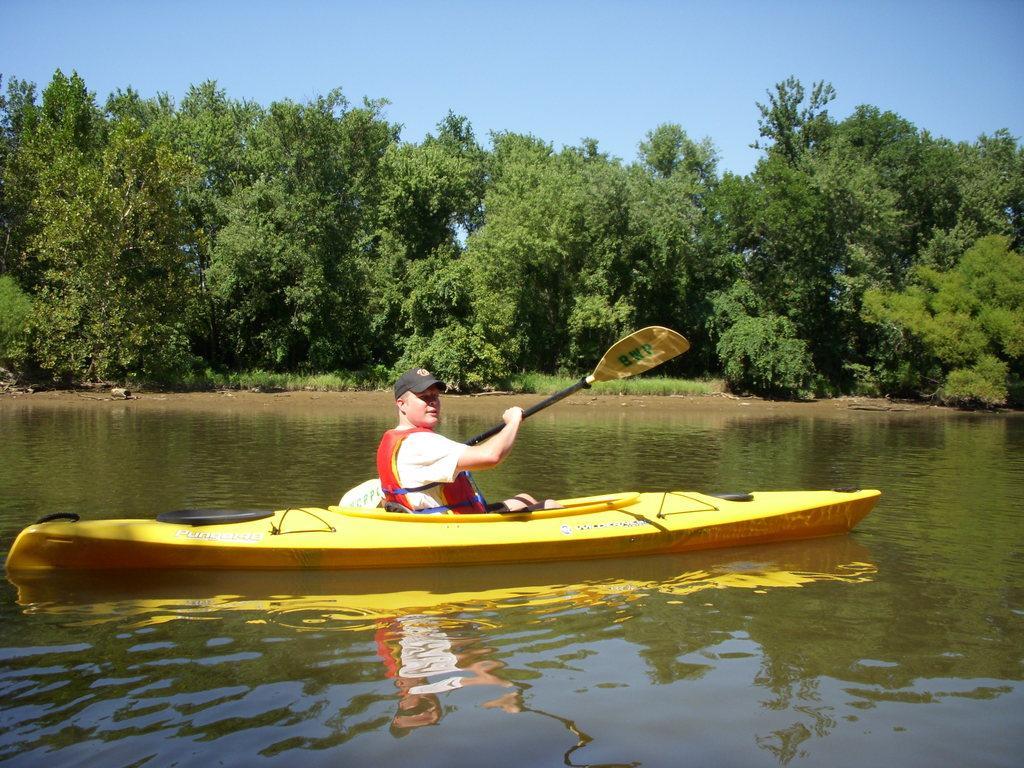Describe this image in one or two sentences. In this image, we can see a person holding a rower and sitting on the boat which is floating on the water. There are some trees in the middle of the image. There is a sky at the top of the image. 